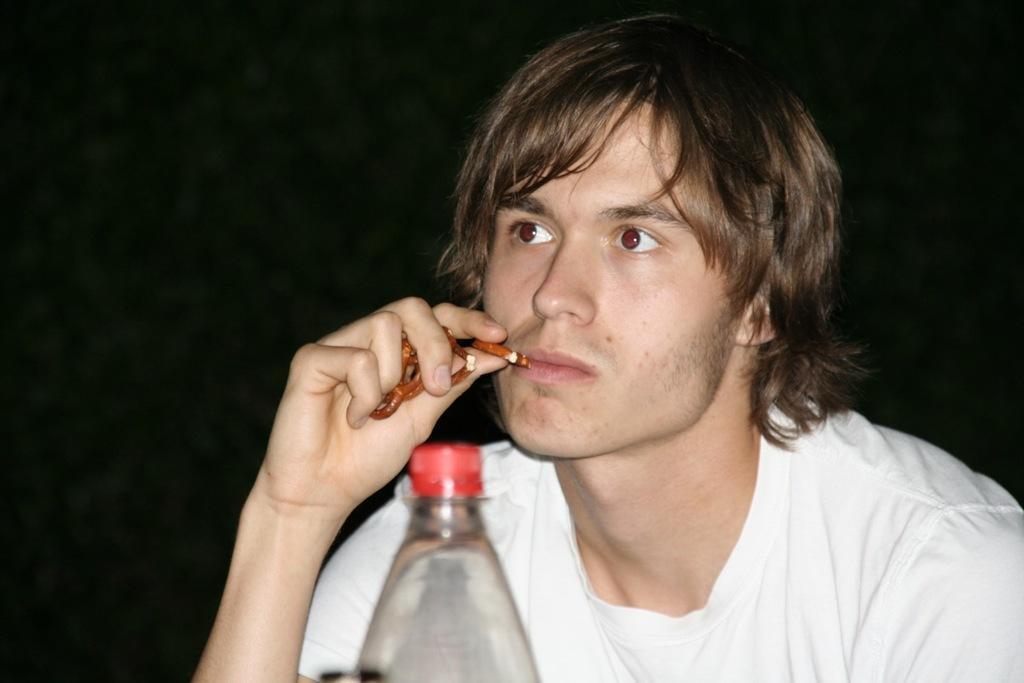Could you give a brief overview of what you see in this image? In the image there is a man holding some food items in the hand. In front of him there is a bottle. Behind him there is a black background. 